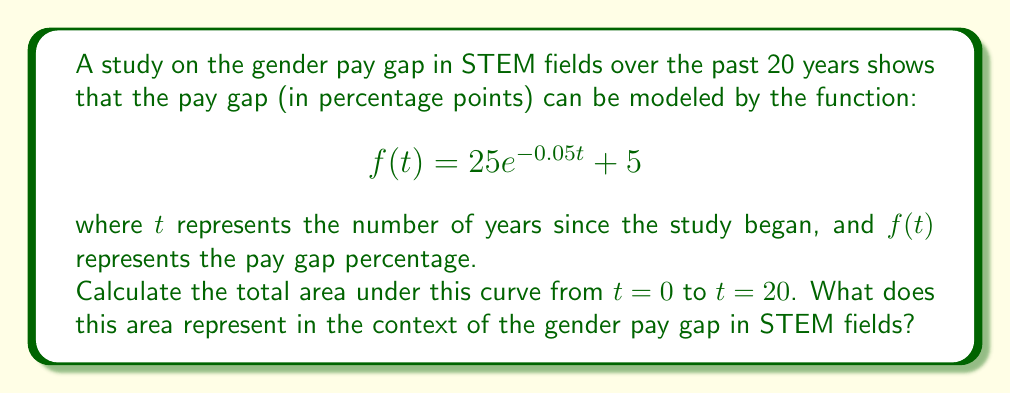Give your solution to this math problem. To solve this problem, we need to use definite integration. The area under the curve is given by the definite integral of $f(t)$ from 0 to 20.

1) First, let's set up the integral:

   $$\int_0^{20} (25e^{-0.05t} + 5) dt$$

2) We can split this into two integrals:

   $$\int_0^{20} 25e^{-0.05t} dt + \int_0^{20} 5 dt$$

3) For the first integral, we use the rule for integrating exponentials:
   
   $$\int e^{ax} dx = \frac{1}{a}e^{ax} + C$$

   Here, $a = -0.05$, so:

   $$25 \int_0^{20} e^{-0.05t} dt = 25 \cdot \frac{1}{-0.05}e^{-0.05t} \big|_0^{20}$$

4) For the second integral, it's a simple integration of a constant:

   $$\int_0^{20} 5 dt = 5t \big|_0^{20}$$

5) Now, let's evaluate these integrals:

   First integral: 
   $$25 \cdot \frac{1}{-0.05}e^{-0.05t} \big|_0^{20} = -500(e^{-1} - 1) \approx 316.06$$

   Second integral:
   $$5t \big|_0^{20} = 100$$

6) Sum the results:

   $$316.06 + 100 = 416.06$$

This area represents the cumulative gender pay gap over the 20-year period. Each unit of area can be interpreted as a "percentage-year" of pay gap.
Answer: The total area under the curve from $t=0$ to $t=20$ is approximately 416.06 percentage-years. This represents the cumulative gender pay gap in STEM fields over the 20-year period studied. 